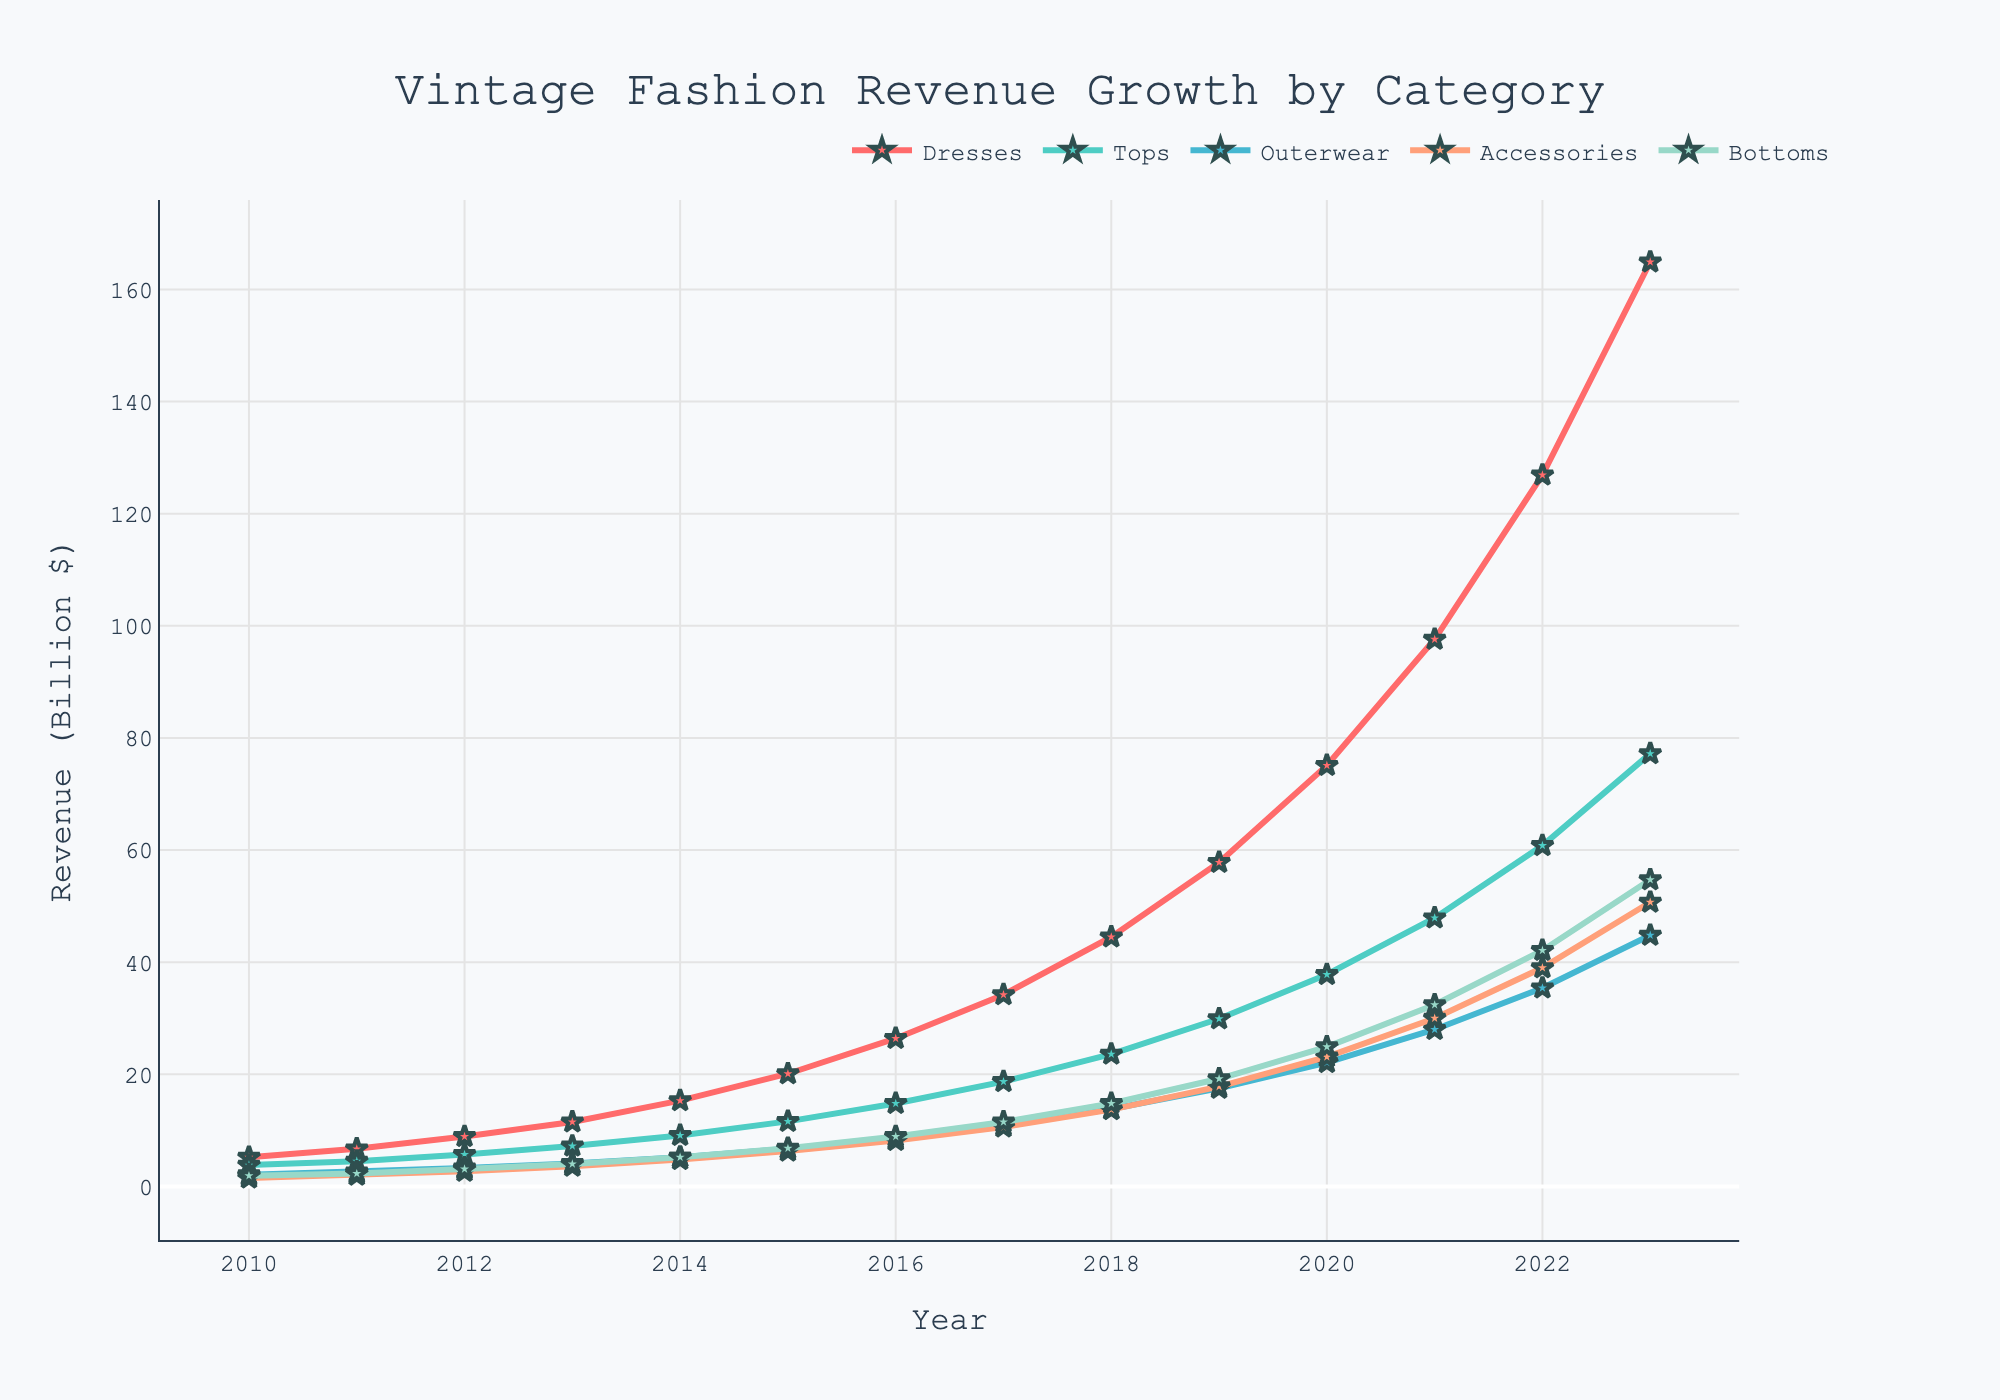Which clothing category had the highest revenue in 2023? Look at the plotted lines on the chart for the year 2023 and identify the highest point. The purple line representing Dresses is the highest in 2023.
Answer: Dresses How much did the revenue for Accessories increase from 2010 to 2023? Subtract the revenue value for Accessories in 2010 from its value in 2023 (50.7 - 1.5 = 49.2).
Answer: 49.2 Between which years did the revenue for Tops see the fastest growth? Look for the segment of the yellow line representing Tops with the steepest incline. The steepest segment is from 2020 to 2021.
Answer: 2020 to 2021 What's the total revenue for Outerwear over the entire period from 2010 to 2023? Sum the revenue values for Outerwear from 2010 to 2023 (2.1 + 2.6 + 3.3 + 4.1 + 5.2 + 6.7 + 8.5 + 10.9 + 13.8 + 17.5 + 22.1 + 28.0 + 35.4 + 44.8 = 204).
Answer: 204 Which year did Dresses surpass 30 billion in revenue? Trace the blue line representing Dresses to see when it first crosses the 30 billion mark. In 2017, Dresses surpasses 30 billion in revenue.
Answer: 2017 Are there any years where the revenue for Bottoms is higher than for Tops? Compare the green and red lines year by year. Bottoms never surpass Tops in any year.
Answer: No What's the difference in revenue between Dresses and Bottoms in 2021? Subtract the revenue for Bottoms from the revenue for Dresses in 2021 (97.6 - 32.4 = 65.2).
Answer: 65.2 What is the average annual revenue for Accessories from 2010 to 2023? Sum all annual revenue values for Accessories and divide by the number of years (1.5 + 2.0 + 2.7 + 3.6 + 4.8 + 6.3 + 8.2 + 10.6 + 13.7 + 17.8 + 23.1 + 30.0 + 39.0 + 50.7 = 213.9; 213.9 / 14 ≈ 15.28 ).
Answer: 15.28 